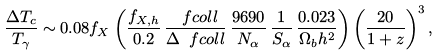Convert formula to latex. <formula><loc_0><loc_0><loc_500><loc_500>\frac { \Delta T _ { c } } { T _ { \gamma } } \sim 0 . 0 8 f _ { X } \left ( \frac { f _ { X , h } } { 0 . 2 } \, \frac { \ f c o l l } { \Delta \ f c o l l } \, \frac { 9 6 9 0 } { N _ { \alpha } } \, \frac { 1 } { S _ { \alpha } } \, \frac { 0 . 0 2 3 } { \Omega _ { b } h ^ { 2 } } \right ) \left ( \frac { 2 0 } { 1 + z } \right ) ^ { 3 } ,</formula> 